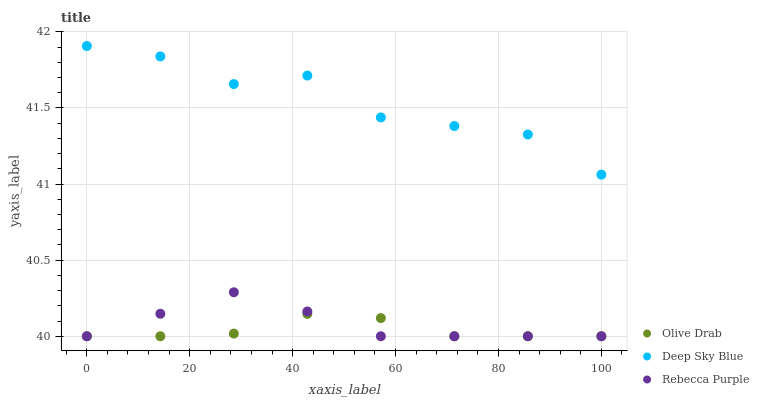Does Olive Drab have the minimum area under the curve?
Answer yes or no. Yes. Does Deep Sky Blue have the maximum area under the curve?
Answer yes or no. Yes. Does Rebecca Purple have the minimum area under the curve?
Answer yes or no. No. Does Rebecca Purple have the maximum area under the curve?
Answer yes or no. No. Is Rebecca Purple the smoothest?
Answer yes or no. Yes. Is Deep Sky Blue the roughest?
Answer yes or no. Yes. Is Olive Drab the smoothest?
Answer yes or no. No. Is Olive Drab the roughest?
Answer yes or no. No. Does Olive Drab have the lowest value?
Answer yes or no. Yes. Does Deep Sky Blue have the highest value?
Answer yes or no. Yes. Does Rebecca Purple have the highest value?
Answer yes or no. No. Is Olive Drab less than Deep Sky Blue?
Answer yes or no. Yes. Is Deep Sky Blue greater than Rebecca Purple?
Answer yes or no. Yes. Does Rebecca Purple intersect Olive Drab?
Answer yes or no. Yes. Is Rebecca Purple less than Olive Drab?
Answer yes or no. No. Is Rebecca Purple greater than Olive Drab?
Answer yes or no. No. Does Olive Drab intersect Deep Sky Blue?
Answer yes or no. No. 